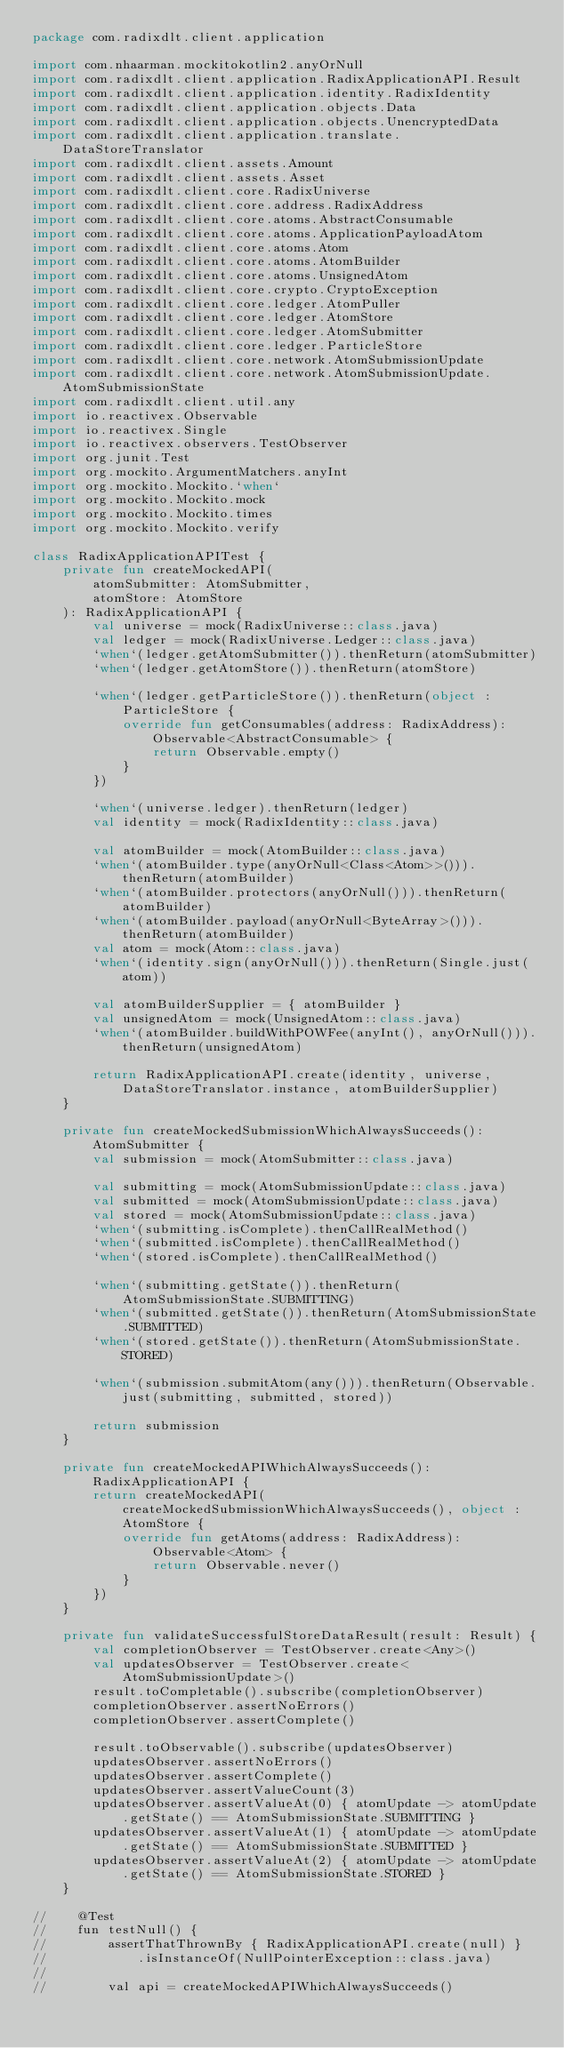<code> <loc_0><loc_0><loc_500><loc_500><_Kotlin_>package com.radixdlt.client.application

import com.nhaarman.mockitokotlin2.anyOrNull
import com.radixdlt.client.application.RadixApplicationAPI.Result
import com.radixdlt.client.application.identity.RadixIdentity
import com.radixdlt.client.application.objects.Data
import com.radixdlt.client.application.objects.UnencryptedData
import com.radixdlt.client.application.translate.DataStoreTranslator
import com.radixdlt.client.assets.Amount
import com.radixdlt.client.assets.Asset
import com.radixdlt.client.core.RadixUniverse
import com.radixdlt.client.core.address.RadixAddress
import com.radixdlt.client.core.atoms.AbstractConsumable
import com.radixdlt.client.core.atoms.ApplicationPayloadAtom
import com.radixdlt.client.core.atoms.Atom
import com.radixdlt.client.core.atoms.AtomBuilder
import com.radixdlt.client.core.atoms.UnsignedAtom
import com.radixdlt.client.core.crypto.CryptoException
import com.radixdlt.client.core.ledger.AtomPuller
import com.radixdlt.client.core.ledger.AtomStore
import com.radixdlt.client.core.ledger.AtomSubmitter
import com.radixdlt.client.core.ledger.ParticleStore
import com.radixdlt.client.core.network.AtomSubmissionUpdate
import com.radixdlt.client.core.network.AtomSubmissionUpdate.AtomSubmissionState
import com.radixdlt.client.util.any
import io.reactivex.Observable
import io.reactivex.Single
import io.reactivex.observers.TestObserver
import org.junit.Test
import org.mockito.ArgumentMatchers.anyInt
import org.mockito.Mockito.`when`
import org.mockito.Mockito.mock
import org.mockito.Mockito.times
import org.mockito.Mockito.verify

class RadixApplicationAPITest {
    private fun createMockedAPI(
        atomSubmitter: AtomSubmitter,
        atomStore: AtomStore
    ): RadixApplicationAPI {
        val universe = mock(RadixUniverse::class.java)
        val ledger = mock(RadixUniverse.Ledger::class.java)
        `when`(ledger.getAtomSubmitter()).thenReturn(atomSubmitter)
        `when`(ledger.getAtomStore()).thenReturn(atomStore)

        `when`(ledger.getParticleStore()).thenReturn(object : ParticleStore {
            override fun getConsumables(address: RadixAddress): Observable<AbstractConsumable> {
                return Observable.empty()
            }
        })

        `when`(universe.ledger).thenReturn(ledger)
        val identity = mock(RadixIdentity::class.java)

        val atomBuilder = mock(AtomBuilder::class.java)
        `when`(atomBuilder.type(anyOrNull<Class<Atom>>())).thenReturn(atomBuilder)
        `when`(atomBuilder.protectors(anyOrNull())).thenReturn(atomBuilder)
        `when`(atomBuilder.payload(anyOrNull<ByteArray>())).thenReturn(atomBuilder)
        val atom = mock(Atom::class.java)
        `when`(identity.sign(anyOrNull())).thenReturn(Single.just(atom))

        val atomBuilderSupplier = { atomBuilder }
        val unsignedAtom = mock(UnsignedAtom::class.java)
        `when`(atomBuilder.buildWithPOWFee(anyInt(), anyOrNull())).thenReturn(unsignedAtom)

        return RadixApplicationAPI.create(identity, universe, DataStoreTranslator.instance, atomBuilderSupplier)
    }

    private fun createMockedSubmissionWhichAlwaysSucceeds(): AtomSubmitter {
        val submission = mock(AtomSubmitter::class.java)

        val submitting = mock(AtomSubmissionUpdate::class.java)
        val submitted = mock(AtomSubmissionUpdate::class.java)
        val stored = mock(AtomSubmissionUpdate::class.java)
        `when`(submitting.isComplete).thenCallRealMethod()
        `when`(submitted.isComplete).thenCallRealMethod()
        `when`(stored.isComplete).thenCallRealMethod()

        `when`(submitting.getState()).thenReturn(AtomSubmissionState.SUBMITTING)
        `when`(submitted.getState()).thenReturn(AtomSubmissionState.SUBMITTED)
        `when`(stored.getState()).thenReturn(AtomSubmissionState.STORED)

        `when`(submission.submitAtom(any())).thenReturn(Observable.just(submitting, submitted, stored))

        return submission
    }

    private fun createMockedAPIWhichAlwaysSucceeds(): RadixApplicationAPI {
        return createMockedAPI(createMockedSubmissionWhichAlwaysSucceeds(), object : AtomStore {
            override fun getAtoms(address: RadixAddress): Observable<Atom> {
                return Observable.never()
            }
        })
    }

    private fun validateSuccessfulStoreDataResult(result: Result) {
        val completionObserver = TestObserver.create<Any>()
        val updatesObserver = TestObserver.create<AtomSubmissionUpdate>()
        result.toCompletable().subscribe(completionObserver)
        completionObserver.assertNoErrors()
        completionObserver.assertComplete()

        result.toObservable().subscribe(updatesObserver)
        updatesObserver.assertNoErrors()
        updatesObserver.assertComplete()
        updatesObserver.assertValueCount(3)
        updatesObserver.assertValueAt(0) { atomUpdate -> atomUpdate.getState() == AtomSubmissionState.SUBMITTING }
        updatesObserver.assertValueAt(1) { atomUpdate -> atomUpdate.getState() == AtomSubmissionState.SUBMITTED }
        updatesObserver.assertValueAt(2) { atomUpdate -> atomUpdate.getState() == AtomSubmissionState.STORED }
    }

//    @Test
//    fun testNull() {
//        assertThatThrownBy { RadixApplicationAPI.create(null) }
//            .isInstanceOf(NullPointerException::class.java)
//
//        val api = createMockedAPIWhichAlwaysSucceeds()</code> 